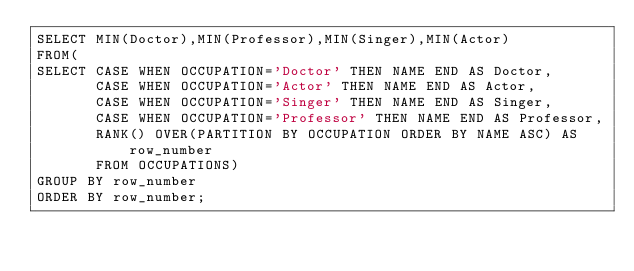Convert code to text. <code><loc_0><loc_0><loc_500><loc_500><_SQL_>SELECT MIN(Doctor),MIN(Professor),MIN(Singer),MIN(Actor)
FROM(
SELECT CASE WHEN OCCUPATION='Doctor' THEN NAME END AS Doctor,
       CASE WHEN OCCUPATION='Actor' THEN NAME END AS Actor,
       CASE WHEN OCCUPATION='Singer' THEN NAME END AS Singer,
       CASE WHEN OCCUPATION='Professor' THEN NAME END AS Professor,
       RANK() OVER(PARTITION BY OCCUPATION ORDER BY NAME ASC) AS row_number
       FROM OCCUPATIONS) 
GROUP BY row_number
ORDER BY row_number;</code> 